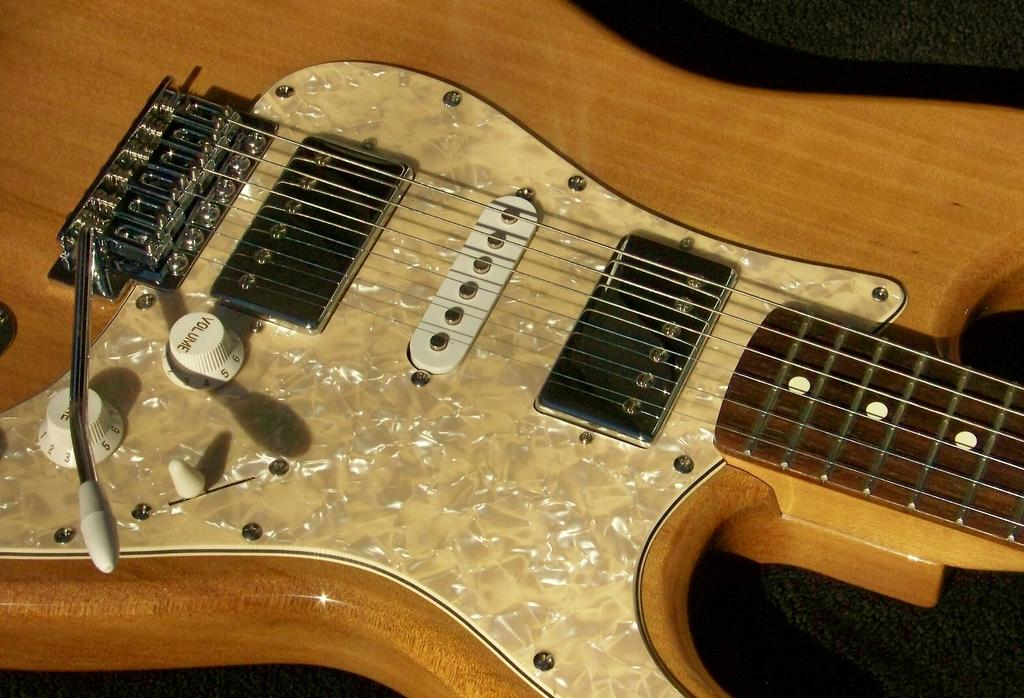What musical instrument is present in the image? There is a guitar in the image. What material is the guitar made of? The guitar is made of wood. What feature allows the guitar to produce sound? The guitar has strings. How can the volume of the guitar be adjusted? There are white knobs on the guitar for increasing volume. What type of punishment is being administered to the guitar in the image? There is no punishment being administered to the guitar in the image; it is simply a musical instrument. 